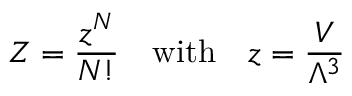<formula> <loc_0><loc_0><loc_500><loc_500>Z = { \frac { z ^ { N } } { N ! } } \quad w i t h \quad z = { \frac { V } { \Lambda ^ { 3 } } }</formula> 